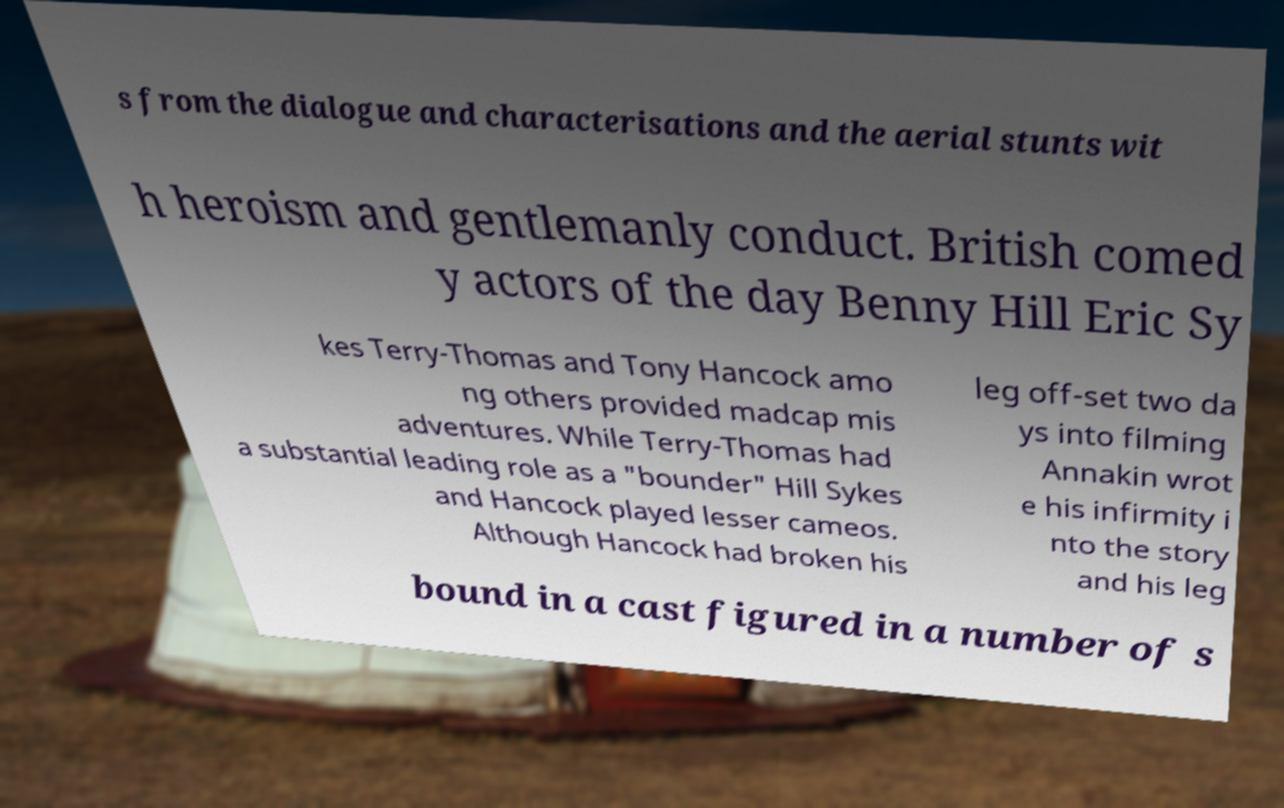Could you assist in decoding the text presented in this image and type it out clearly? s from the dialogue and characterisations and the aerial stunts wit h heroism and gentlemanly conduct. British comed y actors of the day Benny Hill Eric Sy kes Terry-Thomas and Tony Hancock amo ng others provided madcap mis adventures. While Terry-Thomas had a substantial leading role as a "bounder" Hill Sykes and Hancock played lesser cameos. Although Hancock had broken his leg off-set two da ys into filming Annakin wrot e his infirmity i nto the story and his leg bound in a cast figured in a number of s 